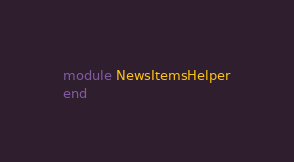Convert code to text. <code><loc_0><loc_0><loc_500><loc_500><_Ruby_>module NewsItemsHelper
end
</code> 